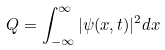<formula> <loc_0><loc_0><loc_500><loc_500>Q = \int ^ { \infty } _ { - \infty } | \psi ( x , t ) | ^ { 2 } d x</formula> 